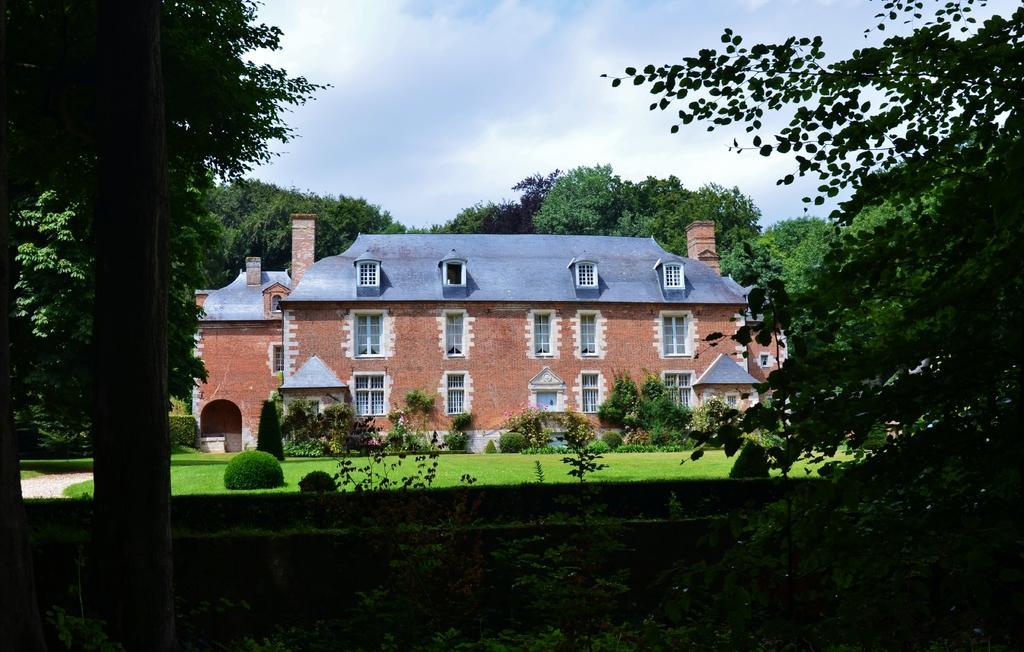In one or two sentences, can you explain what this image depicts? In the image we can see a building and these are the windows of the building. Everywhere there are trees around. Here we can see grass, plants and a cloudy sky. 